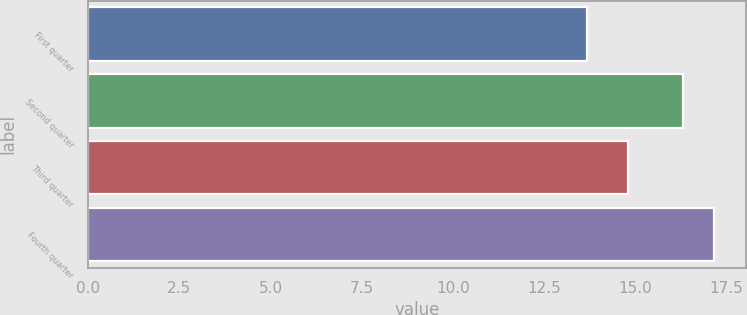Convert chart to OTSL. <chart><loc_0><loc_0><loc_500><loc_500><bar_chart><fcel>First quarter<fcel>Second quarter<fcel>Third quarter<fcel>Fourth quarter<nl><fcel>13.67<fcel>16.32<fcel>14.79<fcel>17.17<nl></chart> 